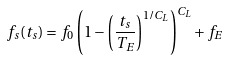<formula> <loc_0><loc_0><loc_500><loc_500>f _ { s } ( t _ { s } ) = f _ { 0 } \left ( 1 - \left ( \frac { t _ { s } } { T _ { E } } \right ) ^ { 1 / C _ { L } } \right ) ^ { C _ { L } } + f _ { E }</formula> 